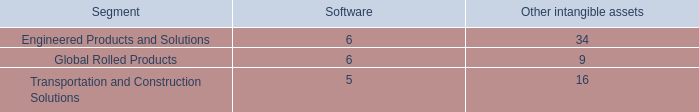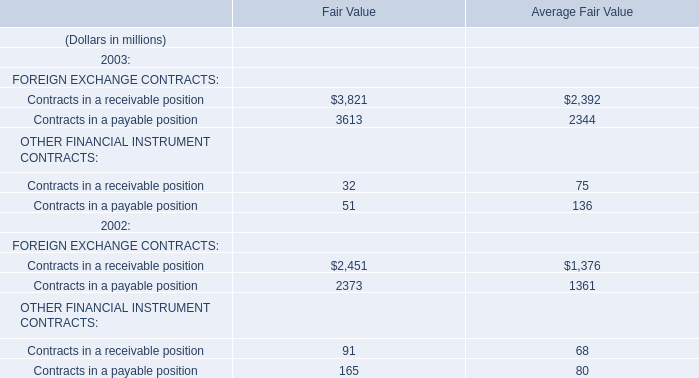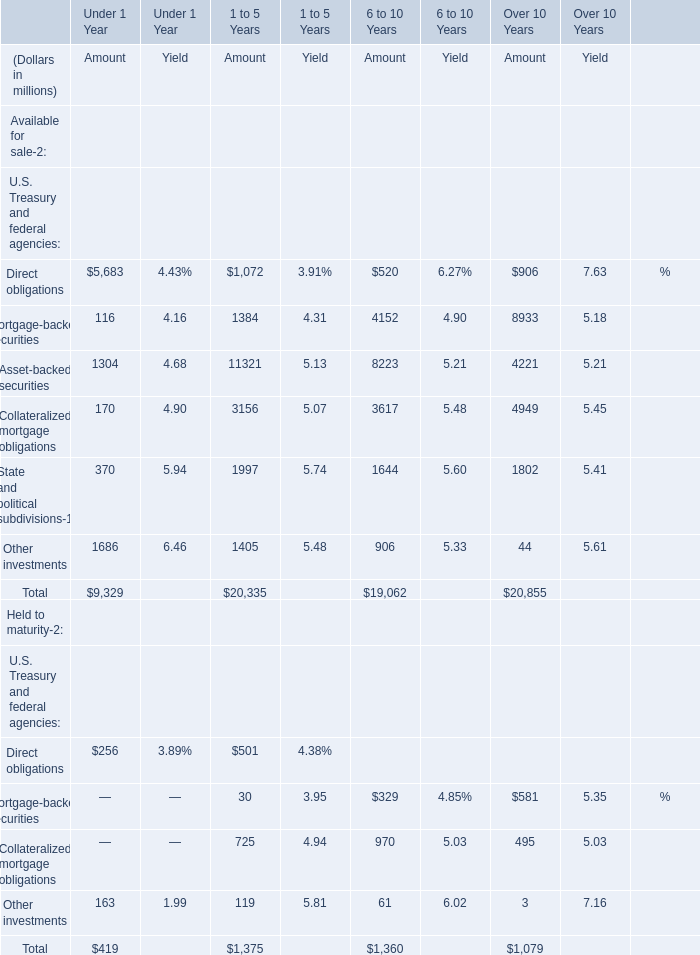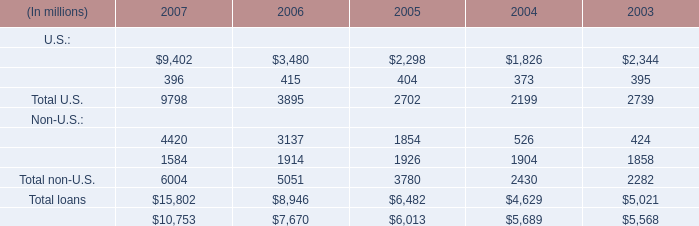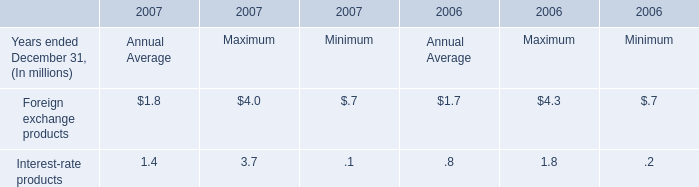What's the amount of Asset-backed securities in terms of Available for sale for 1 to 5 Years ? (in million) 
Answer: 11321. 